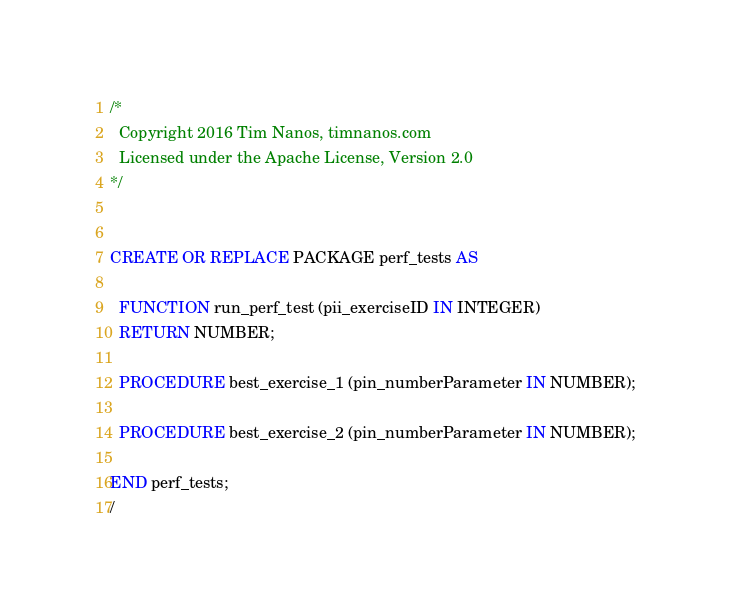<code> <loc_0><loc_0><loc_500><loc_500><_SQL_>/*
  Copyright 2016 Tim Nanos, timnanos.com
  Licensed under the Apache License, Version 2.0
*/


CREATE OR REPLACE PACKAGE perf_tests AS 

  FUNCTION run_perf_test (pii_exerciseID IN INTEGER)
  RETURN NUMBER;

  PROCEDURE best_exercise_1 (pin_numberParameter IN NUMBER);

  PROCEDURE best_exercise_2 (pin_numberParameter IN NUMBER);

END perf_tests; 
/ 
</code> 